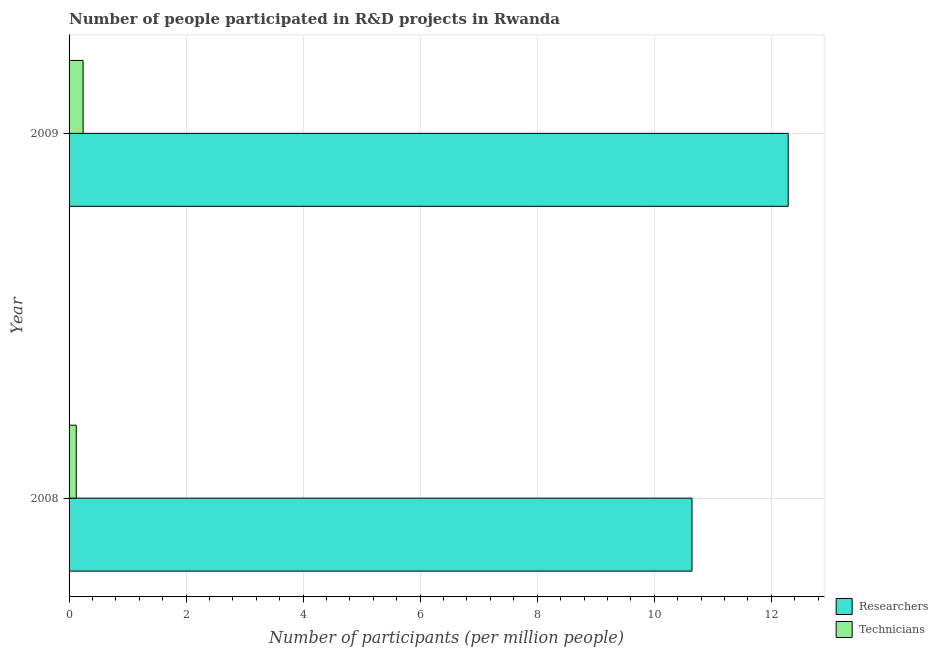How many different coloured bars are there?
Your answer should be compact. 2. Are the number of bars per tick equal to the number of legend labels?
Keep it short and to the point. Yes. Are the number of bars on each tick of the Y-axis equal?
Keep it short and to the point. Yes. How many bars are there on the 1st tick from the bottom?
Offer a terse response. 2. What is the label of the 1st group of bars from the top?
Provide a succinct answer. 2009. What is the number of technicians in 2008?
Your response must be concise. 0.12. Across all years, what is the maximum number of researchers?
Provide a succinct answer. 12.29. Across all years, what is the minimum number of technicians?
Offer a terse response. 0.12. In which year was the number of technicians maximum?
Make the answer very short. 2009. What is the total number of researchers in the graph?
Provide a short and direct response. 22.94. What is the difference between the number of researchers in 2008 and that in 2009?
Your answer should be very brief. -1.64. What is the difference between the number of technicians in 2009 and the number of researchers in 2008?
Give a very brief answer. -10.41. What is the average number of technicians per year?
Give a very brief answer. 0.18. In the year 2008, what is the difference between the number of researchers and number of technicians?
Your response must be concise. 10.52. What is the ratio of the number of researchers in 2008 to that in 2009?
Provide a succinct answer. 0.87. Is the difference between the number of researchers in 2008 and 2009 greater than the difference between the number of technicians in 2008 and 2009?
Offer a very short reply. No. What does the 2nd bar from the top in 2008 represents?
Offer a very short reply. Researchers. What does the 1st bar from the bottom in 2008 represents?
Your answer should be very brief. Researchers. Are the values on the major ticks of X-axis written in scientific E-notation?
Make the answer very short. No. Does the graph contain grids?
Give a very brief answer. Yes. How are the legend labels stacked?
Provide a succinct answer. Vertical. What is the title of the graph?
Keep it short and to the point. Number of people participated in R&D projects in Rwanda. Does "Commercial service imports" appear as one of the legend labels in the graph?
Make the answer very short. No. What is the label or title of the X-axis?
Provide a short and direct response. Number of participants (per million people). What is the Number of participants (per million people) in Researchers in 2008?
Your response must be concise. 10.65. What is the Number of participants (per million people) of Technicians in 2008?
Provide a short and direct response. 0.12. What is the Number of participants (per million people) of Researchers in 2009?
Your answer should be very brief. 12.29. What is the Number of participants (per million people) in Technicians in 2009?
Your answer should be compact. 0.24. Across all years, what is the maximum Number of participants (per million people) of Researchers?
Your answer should be very brief. 12.29. Across all years, what is the maximum Number of participants (per million people) in Technicians?
Keep it short and to the point. 0.24. Across all years, what is the minimum Number of participants (per million people) in Researchers?
Keep it short and to the point. 10.65. Across all years, what is the minimum Number of participants (per million people) of Technicians?
Give a very brief answer. 0.12. What is the total Number of participants (per million people) of Researchers in the graph?
Your answer should be very brief. 22.94. What is the total Number of participants (per million people) in Technicians in the graph?
Your answer should be very brief. 0.36. What is the difference between the Number of participants (per million people) of Researchers in 2008 and that in 2009?
Make the answer very short. -1.64. What is the difference between the Number of participants (per million people) of Technicians in 2008 and that in 2009?
Keep it short and to the point. -0.12. What is the difference between the Number of participants (per million people) of Researchers in 2008 and the Number of participants (per million people) of Technicians in 2009?
Your response must be concise. 10.41. What is the average Number of participants (per million people) of Researchers per year?
Your answer should be very brief. 11.47. What is the average Number of participants (per million people) in Technicians per year?
Offer a very short reply. 0.18. In the year 2008, what is the difference between the Number of participants (per million people) in Researchers and Number of participants (per million people) in Technicians?
Ensure brevity in your answer.  10.52. In the year 2009, what is the difference between the Number of participants (per million people) in Researchers and Number of participants (per million people) in Technicians?
Your answer should be very brief. 12.05. What is the ratio of the Number of participants (per million people) in Researchers in 2008 to that in 2009?
Make the answer very short. 0.87. What is the ratio of the Number of participants (per million people) of Technicians in 2008 to that in 2009?
Your response must be concise. 0.51. What is the difference between the highest and the second highest Number of participants (per million people) of Researchers?
Ensure brevity in your answer.  1.64. What is the difference between the highest and the second highest Number of participants (per million people) in Technicians?
Make the answer very short. 0.12. What is the difference between the highest and the lowest Number of participants (per million people) in Researchers?
Keep it short and to the point. 1.64. What is the difference between the highest and the lowest Number of participants (per million people) in Technicians?
Offer a terse response. 0.12. 